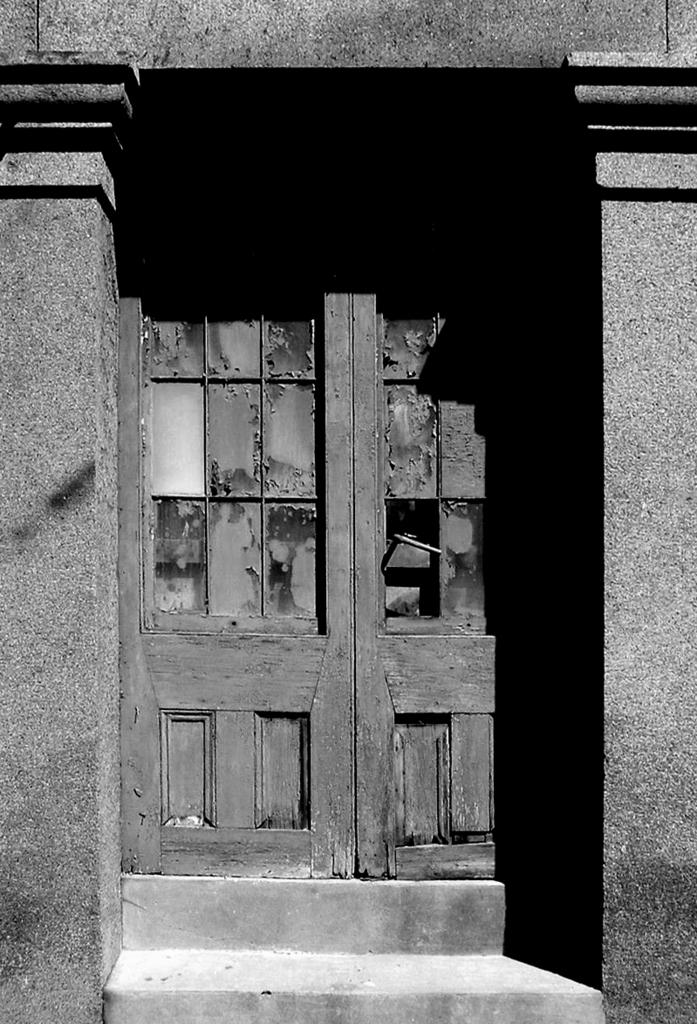What structures are located in the foreground of the image? There are pillars and a door in the foreground of the image. Can you describe the door in the image? The door is located in the foreground of the image. What type of ear can be seen on the giraffe in the image? There is no giraffe present in the image, so there is no ear to observe. 